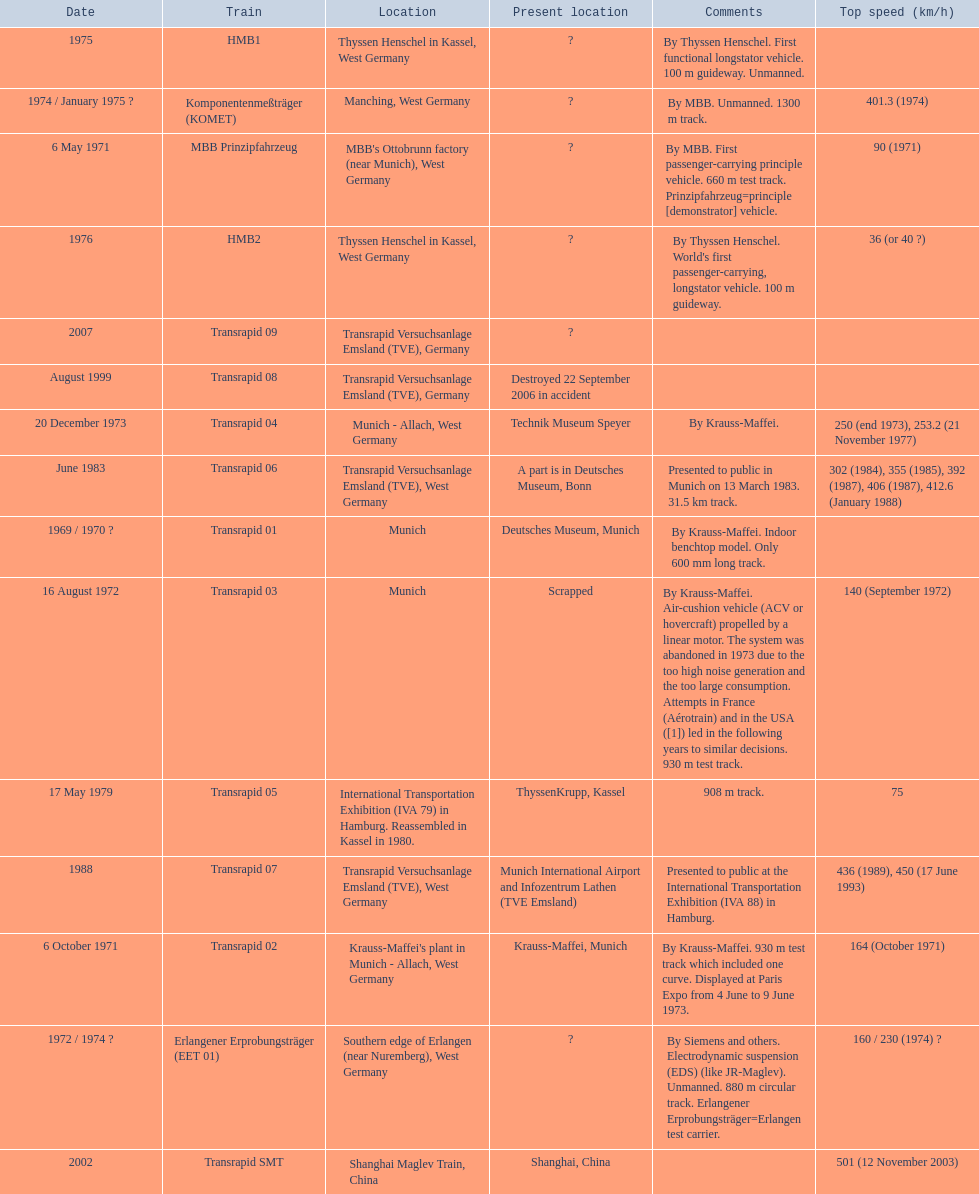What train was developed after the erlangener erprobungstrager? Transrapid 04. 